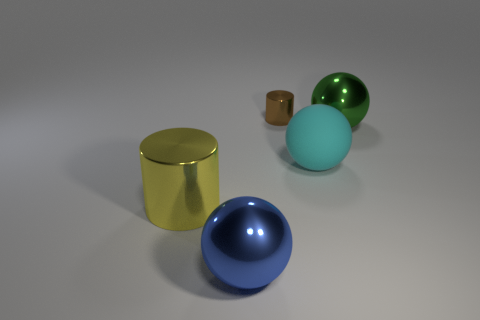How many objects are there in the image? There are five objects in the image, set against a neutral background, consisting of a cylinder, a cube, and three spheres that vary in size and color. 